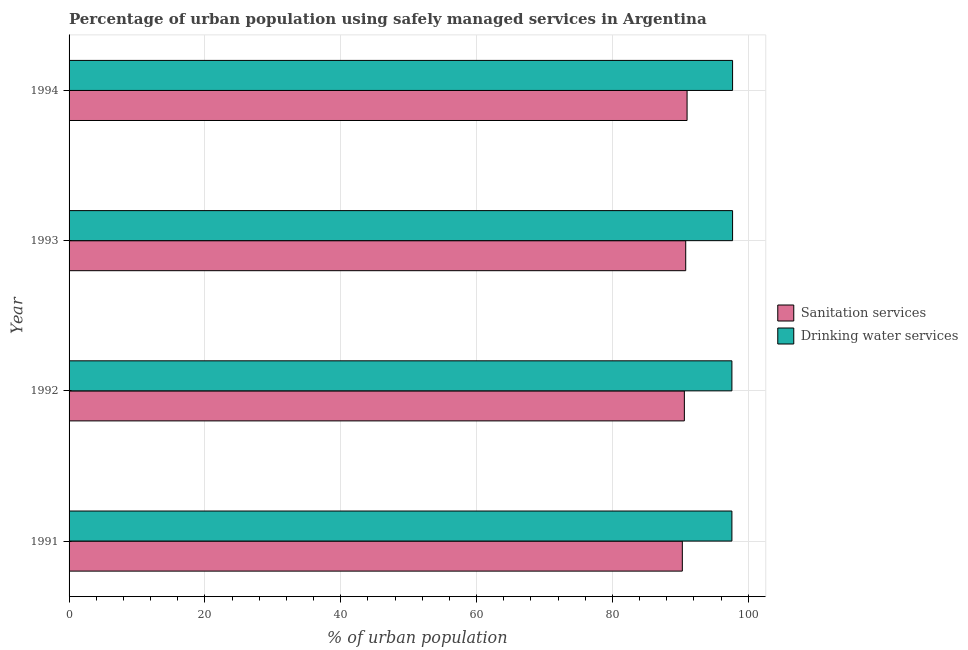How many different coloured bars are there?
Make the answer very short. 2. Are the number of bars per tick equal to the number of legend labels?
Your answer should be very brief. Yes. How many bars are there on the 2nd tick from the bottom?
Offer a very short reply. 2. In how many cases, is the number of bars for a given year not equal to the number of legend labels?
Provide a succinct answer. 0. What is the percentage of urban population who used sanitation services in 1992?
Offer a terse response. 90.6. Across all years, what is the maximum percentage of urban population who used sanitation services?
Provide a short and direct response. 91. Across all years, what is the minimum percentage of urban population who used drinking water services?
Ensure brevity in your answer.  97.6. What is the total percentage of urban population who used sanitation services in the graph?
Keep it short and to the point. 362.7. What is the difference between the percentage of urban population who used sanitation services in 1991 and that in 1992?
Provide a succinct answer. -0.3. What is the difference between the percentage of urban population who used sanitation services in 1992 and the percentage of urban population who used drinking water services in 1993?
Ensure brevity in your answer.  -7.1. What is the average percentage of urban population who used sanitation services per year?
Offer a terse response. 90.67. Is the percentage of urban population who used drinking water services in 1992 less than that in 1994?
Your answer should be very brief. Yes. What is the difference between the highest and the second highest percentage of urban population who used sanitation services?
Offer a very short reply. 0.2. What is the difference between the highest and the lowest percentage of urban population who used drinking water services?
Provide a short and direct response. 0.1. Is the sum of the percentage of urban population who used drinking water services in 1991 and 1992 greater than the maximum percentage of urban population who used sanitation services across all years?
Provide a succinct answer. Yes. What does the 1st bar from the top in 1993 represents?
Provide a short and direct response. Drinking water services. What does the 2nd bar from the bottom in 1993 represents?
Offer a very short reply. Drinking water services. Are all the bars in the graph horizontal?
Your answer should be compact. Yes. What is the difference between two consecutive major ticks on the X-axis?
Your answer should be compact. 20. Does the graph contain any zero values?
Make the answer very short. No. Does the graph contain grids?
Provide a succinct answer. Yes. Where does the legend appear in the graph?
Provide a succinct answer. Center right. How many legend labels are there?
Offer a terse response. 2. How are the legend labels stacked?
Ensure brevity in your answer.  Vertical. What is the title of the graph?
Offer a very short reply. Percentage of urban population using safely managed services in Argentina. What is the label or title of the X-axis?
Ensure brevity in your answer.  % of urban population. What is the % of urban population of Sanitation services in 1991?
Give a very brief answer. 90.3. What is the % of urban population of Drinking water services in 1991?
Provide a short and direct response. 97.6. What is the % of urban population of Sanitation services in 1992?
Provide a succinct answer. 90.6. What is the % of urban population in Drinking water services in 1992?
Keep it short and to the point. 97.6. What is the % of urban population of Sanitation services in 1993?
Ensure brevity in your answer.  90.8. What is the % of urban population of Drinking water services in 1993?
Provide a succinct answer. 97.7. What is the % of urban population in Sanitation services in 1994?
Make the answer very short. 91. What is the % of urban population in Drinking water services in 1994?
Provide a succinct answer. 97.7. Across all years, what is the maximum % of urban population of Sanitation services?
Your response must be concise. 91. Across all years, what is the maximum % of urban population of Drinking water services?
Offer a very short reply. 97.7. Across all years, what is the minimum % of urban population of Sanitation services?
Provide a succinct answer. 90.3. Across all years, what is the minimum % of urban population in Drinking water services?
Your response must be concise. 97.6. What is the total % of urban population in Sanitation services in the graph?
Make the answer very short. 362.7. What is the total % of urban population of Drinking water services in the graph?
Your answer should be compact. 390.6. What is the difference between the % of urban population of Drinking water services in 1991 and that in 1992?
Make the answer very short. 0. What is the difference between the % of urban population of Drinking water services in 1991 and that in 1993?
Make the answer very short. -0.1. What is the difference between the % of urban population of Sanitation services in 1991 and that in 1994?
Give a very brief answer. -0.7. What is the difference between the % of urban population in Drinking water services in 1991 and that in 1994?
Ensure brevity in your answer.  -0.1. What is the difference between the % of urban population of Drinking water services in 1992 and that in 1993?
Ensure brevity in your answer.  -0.1. What is the difference between the % of urban population in Drinking water services in 1992 and that in 1994?
Your answer should be very brief. -0.1. What is the difference between the % of urban population of Sanitation services in 1993 and that in 1994?
Provide a succinct answer. -0.2. What is the difference between the % of urban population of Drinking water services in 1993 and that in 1994?
Your answer should be very brief. 0. What is the difference between the % of urban population of Sanitation services in 1991 and the % of urban population of Drinking water services in 1992?
Provide a short and direct response. -7.3. What is the difference between the % of urban population in Sanitation services in 1991 and the % of urban population in Drinking water services in 1994?
Make the answer very short. -7.4. What is the difference between the % of urban population in Sanitation services in 1992 and the % of urban population in Drinking water services in 1993?
Make the answer very short. -7.1. What is the average % of urban population of Sanitation services per year?
Give a very brief answer. 90.67. What is the average % of urban population of Drinking water services per year?
Your response must be concise. 97.65. In the year 1992, what is the difference between the % of urban population in Sanitation services and % of urban population in Drinking water services?
Give a very brief answer. -7. In the year 1993, what is the difference between the % of urban population of Sanitation services and % of urban population of Drinking water services?
Your answer should be compact. -6.9. What is the ratio of the % of urban population of Sanitation services in 1991 to that in 1992?
Ensure brevity in your answer.  1. What is the ratio of the % of urban population of Drinking water services in 1991 to that in 1993?
Give a very brief answer. 1. What is the ratio of the % of urban population in Sanitation services in 1992 to that in 1993?
Keep it short and to the point. 1. What is the ratio of the % of urban population of Sanitation services in 1993 to that in 1994?
Your answer should be compact. 1. What is the difference between the highest and the second highest % of urban population of Sanitation services?
Keep it short and to the point. 0.2. What is the difference between the highest and the second highest % of urban population of Drinking water services?
Ensure brevity in your answer.  0. 